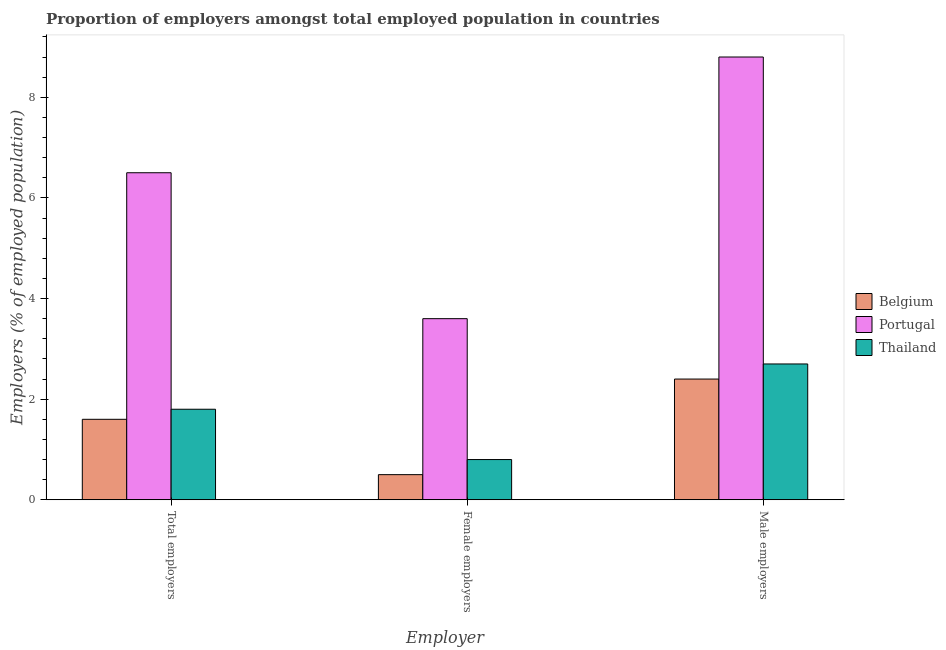How many different coloured bars are there?
Give a very brief answer. 3. Are the number of bars per tick equal to the number of legend labels?
Offer a very short reply. Yes. Are the number of bars on each tick of the X-axis equal?
Provide a short and direct response. Yes. How many bars are there on the 1st tick from the right?
Provide a succinct answer. 3. What is the label of the 2nd group of bars from the left?
Provide a succinct answer. Female employers. What is the percentage of female employers in Portugal?
Offer a terse response. 3.6. Across all countries, what is the maximum percentage of total employers?
Offer a very short reply. 6.5. Across all countries, what is the minimum percentage of total employers?
Give a very brief answer. 1.6. In which country was the percentage of female employers maximum?
Offer a very short reply. Portugal. What is the total percentage of female employers in the graph?
Offer a very short reply. 4.9. What is the difference between the percentage of total employers in Portugal and that in Thailand?
Offer a very short reply. 4.7. What is the difference between the percentage of total employers in Belgium and the percentage of female employers in Thailand?
Keep it short and to the point. 0.8. What is the average percentage of female employers per country?
Provide a short and direct response. 1.63. What is the difference between the percentage of male employers and percentage of total employers in Belgium?
Keep it short and to the point. 0.8. What is the ratio of the percentage of male employers in Belgium to that in Portugal?
Keep it short and to the point. 0.27. What is the difference between the highest and the second highest percentage of female employers?
Offer a terse response. 2.8. What is the difference between the highest and the lowest percentage of male employers?
Your answer should be very brief. 6.4. In how many countries, is the percentage of total employers greater than the average percentage of total employers taken over all countries?
Ensure brevity in your answer.  1. Is the sum of the percentage of total employers in Belgium and Thailand greater than the maximum percentage of male employers across all countries?
Provide a succinct answer. No. What does the 3rd bar from the left in Total employers represents?
Provide a succinct answer. Thailand. What does the 2nd bar from the right in Female employers represents?
Your answer should be compact. Portugal. Is it the case that in every country, the sum of the percentage of total employers and percentage of female employers is greater than the percentage of male employers?
Provide a succinct answer. No. How many bars are there?
Offer a terse response. 9. What is the difference between two consecutive major ticks on the Y-axis?
Give a very brief answer. 2. Are the values on the major ticks of Y-axis written in scientific E-notation?
Keep it short and to the point. No. Does the graph contain any zero values?
Keep it short and to the point. No. Does the graph contain grids?
Make the answer very short. No. How many legend labels are there?
Provide a short and direct response. 3. How are the legend labels stacked?
Your response must be concise. Vertical. What is the title of the graph?
Provide a succinct answer. Proportion of employers amongst total employed population in countries. Does "Cyprus" appear as one of the legend labels in the graph?
Offer a terse response. No. What is the label or title of the X-axis?
Your answer should be compact. Employer. What is the label or title of the Y-axis?
Offer a very short reply. Employers (% of employed population). What is the Employers (% of employed population) of Belgium in Total employers?
Provide a succinct answer. 1.6. What is the Employers (% of employed population) of Portugal in Total employers?
Provide a succinct answer. 6.5. What is the Employers (% of employed population) of Thailand in Total employers?
Your answer should be compact. 1.8. What is the Employers (% of employed population) in Portugal in Female employers?
Ensure brevity in your answer.  3.6. What is the Employers (% of employed population) of Thailand in Female employers?
Make the answer very short. 0.8. What is the Employers (% of employed population) of Belgium in Male employers?
Provide a short and direct response. 2.4. What is the Employers (% of employed population) of Portugal in Male employers?
Your answer should be compact. 8.8. What is the Employers (% of employed population) in Thailand in Male employers?
Provide a short and direct response. 2.7. Across all Employer, what is the maximum Employers (% of employed population) of Belgium?
Keep it short and to the point. 2.4. Across all Employer, what is the maximum Employers (% of employed population) of Portugal?
Provide a short and direct response. 8.8. Across all Employer, what is the maximum Employers (% of employed population) of Thailand?
Offer a very short reply. 2.7. Across all Employer, what is the minimum Employers (% of employed population) of Portugal?
Provide a short and direct response. 3.6. Across all Employer, what is the minimum Employers (% of employed population) in Thailand?
Keep it short and to the point. 0.8. What is the total Employers (% of employed population) of Belgium in the graph?
Your answer should be very brief. 4.5. What is the total Employers (% of employed population) of Portugal in the graph?
Your answer should be very brief. 18.9. What is the total Employers (% of employed population) of Thailand in the graph?
Offer a terse response. 5.3. What is the difference between the Employers (% of employed population) of Belgium in Total employers and that in Female employers?
Offer a terse response. 1.1. What is the difference between the Employers (% of employed population) in Portugal in Total employers and that in Female employers?
Provide a short and direct response. 2.9. What is the difference between the Employers (% of employed population) in Belgium in Total employers and the Employers (% of employed population) in Portugal in Female employers?
Make the answer very short. -2. What is the difference between the Employers (% of employed population) of Portugal in Total employers and the Employers (% of employed population) of Thailand in Male employers?
Make the answer very short. 3.8. What is the difference between the Employers (% of employed population) of Belgium in Female employers and the Employers (% of employed population) of Thailand in Male employers?
Your answer should be compact. -2.2. What is the average Employers (% of employed population) in Belgium per Employer?
Offer a very short reply. 1.5. What is the average Employers (% of employed population) of Portugal per Employer?
Offer a terse response. 6.3. What is the average Employers (% of employed population) in Thailand per Employer?
Offer a very short reply. 1.77. What is the difference between the Employers (% of employed population) of Belgium and Employers (% of employed population) of Thailand in Total employers?
Keep it short and to the point. -0.2. What is the difference between the Employers (% of employed population) of Belgium and Employers (% of employed population) of Thailand in Male employers?
Ensure brevity in your answer.  -0.3. What is the ratio of the Employers (% of employed population) in Portugal in Total employers to that in Female employers?
Your response must be concise. 1.81. What is the ratio of the Employers (% of employed population) in Thailand in Total employers to that in Female employers?
Provide a short and direct response. 2.25. What is the ratio of the Employers (% of employed population) in Portugal in Total employers to that in Male employers?
Your answer should be very brief. 0.74. What is the ratio of the Employers (% of employed population) in Belgium in Female employers to that in Male employers?
Your answer should be compact. 0.21. What is the ratio of the Employers (% of employed population) of Portugal in Female employers to that in Male employers?
Give a very brief answer. 0.41. What is the ratio of the Employers (% of employed population) of Thailand in Female employers to that in Male employers?
Ensure brevity in your answer.  0.3. What is the difference between the highest and the second highest Employers (% of employed population) in Belgium?
Offer a very short reply. 0.8. What is the difference between the highest and the second highest Employers (% of employed population) of Portugal?
Keep it short and to the point. 2.3. What is the difference between the highest and the second highest Employers (% of employed population) in Thailand?
Offer a terse response. 0.9. What is the difference between the highest and the lowest Employers (% of employed population) in Thailand?
Your response must be concise. 1.9. 